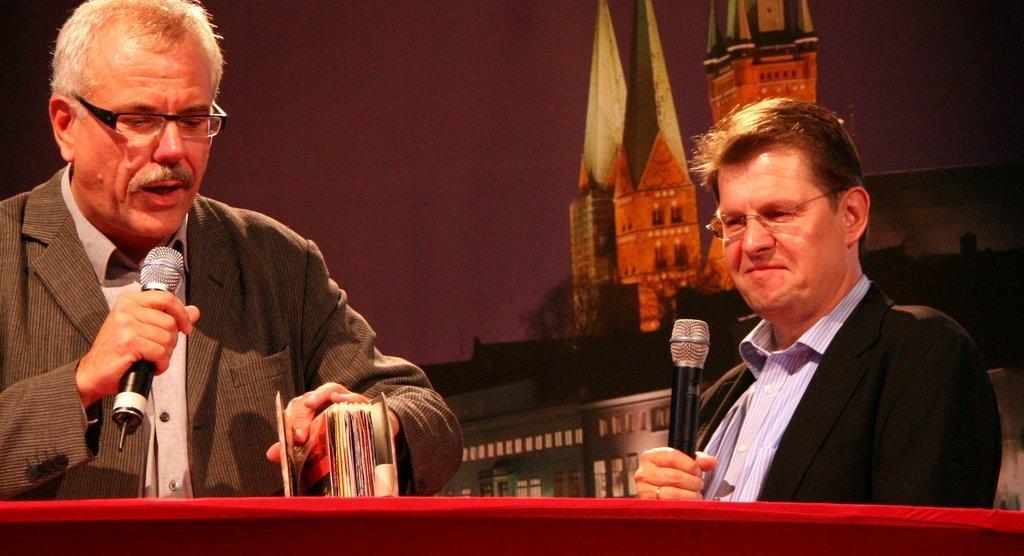In one or two sentences, can you explain what this image depicts? This picture shows a man speaking with the help of a microphone and he holds a book in his hand and we see other man looking at the book and holds a microphone in his hand. and we see a table in front of 